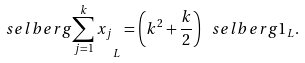Convert formula to latex. <formula><loc_0><loc_0><loc_500><loc_500>\ s e l b e r g { \sum _ { j = 1 } ^ { k } x _ { j } } _ { L } = \left ( k ^ { 2 } + \frac { k } { 2 } \right ) \ s e l b e r g { 1 } _ { L } .</formula> 